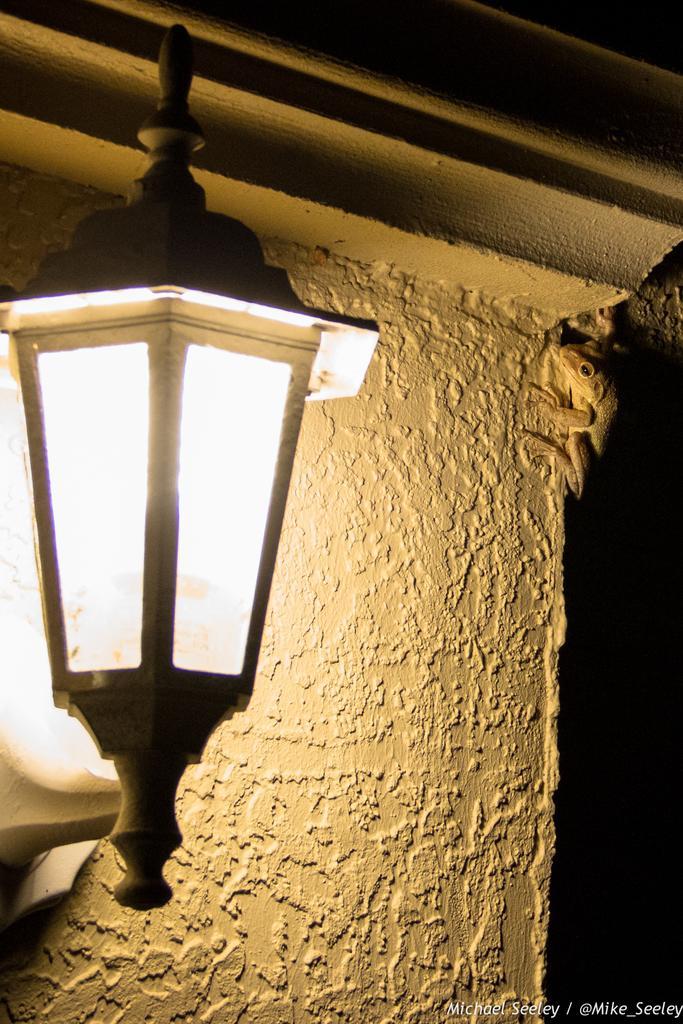Could you give a brief overview of what you see in this image? In this image in the foreground there is one light, and in the background there is a wall and on the wall there is one lizard. 